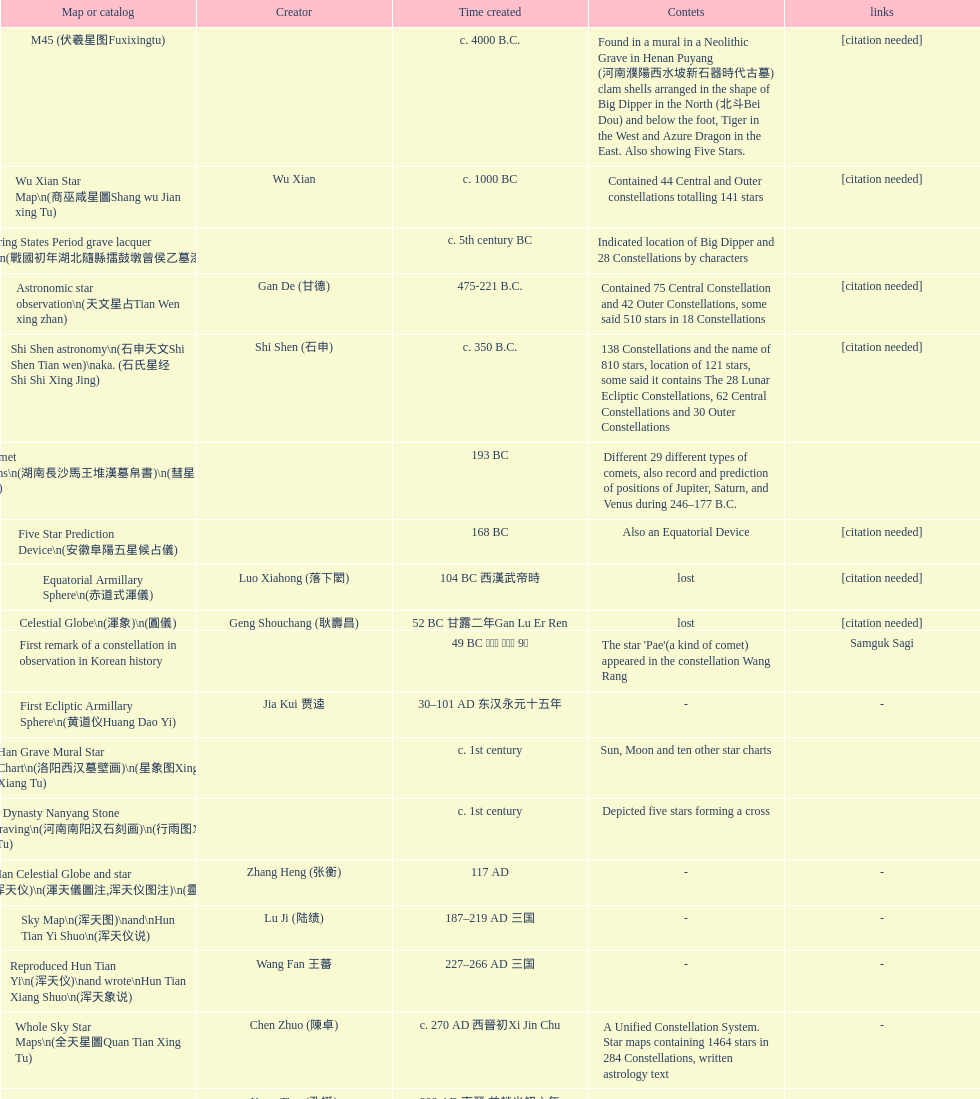Mention three items that were produced not far apart from the time the equatorial armillary sphere was invented. Celestial Globe (渾象) (圓儀), First remark of a constellation in observation in Korean history, First Ecliptic Armillary Sphere (黄道仪Huang Dao Yi). 